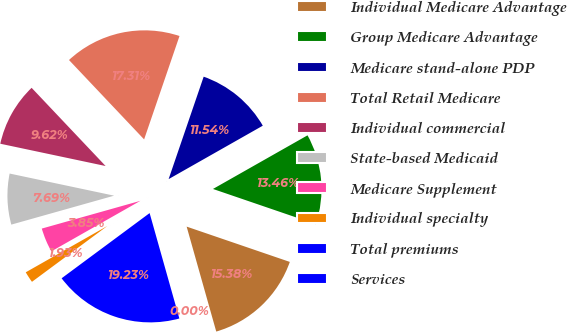Convert chart to OTSL. <chart><loc_0><loc_0><loc_500><loc_500><pie_chart><fcel>Individual Medicare Advantage<fcel>Group Medicare Advantage<fcel>Medicare stand-alone PDP<fcel>Total Retail Medicare<fcel>Individual commercial<fcel>State-based Medicaid<fcel>Medicare Supplement<fcel>Individual specialty<fcel>Total premiums<fcel>Services<nl><fcel>15.38%<fcel>13.46%<fcel>11.54%<fcel>17.31%<fcel>9.62%<fcel>7.69%<fcel>3.85%<fcel>1.93%<fcel>19.23%<fcel>0.0%<nl></chart> 